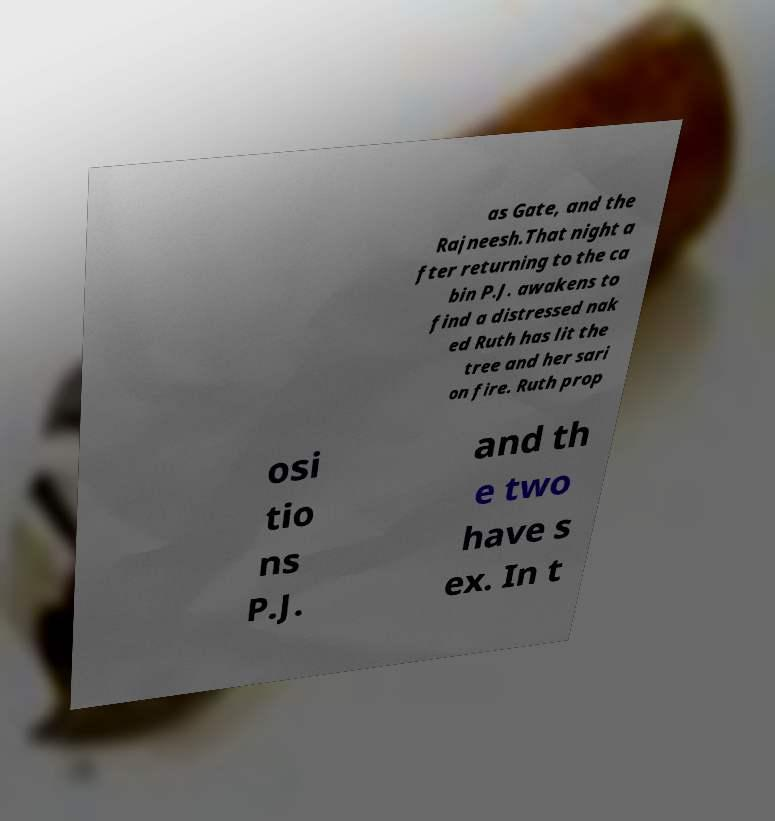Can you accurately transcribe the text from the provided image for me? as Gate, and the Rajneesh.That night a fter returning to the ca bin P.J. awakens to find a distressed nak ed Ruth has lit the tree and her sari on fire. Ruth prop osi tio ns P.J. and th e two have s ex. In t 